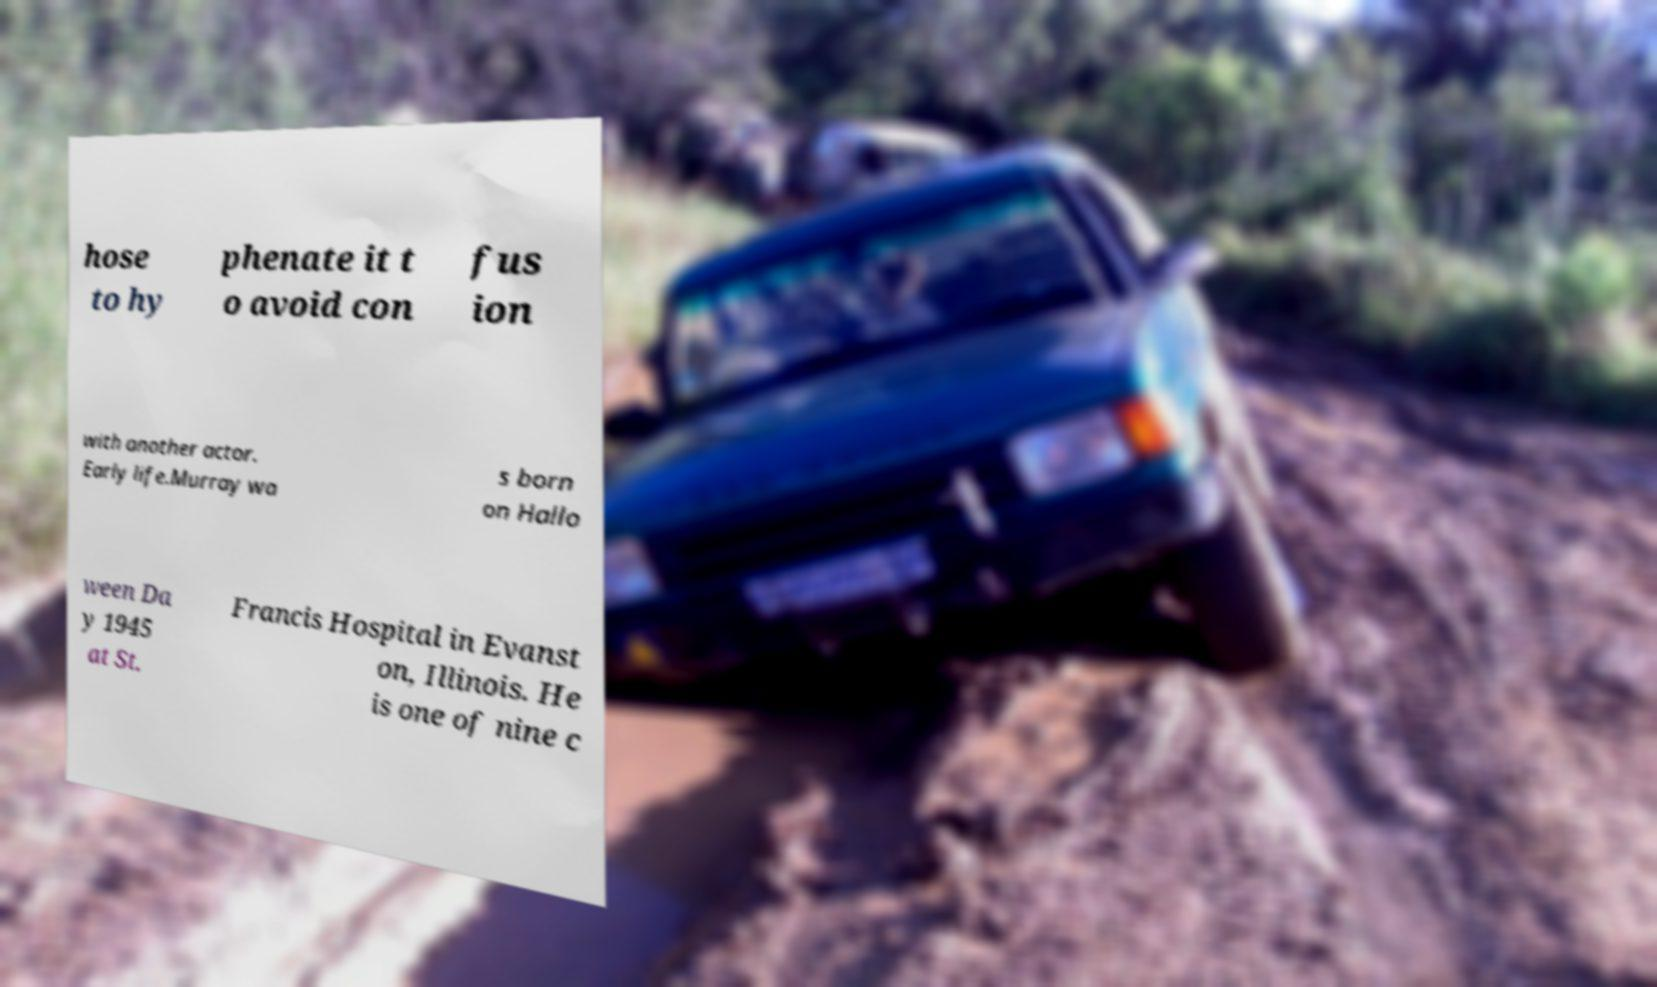For documentation purposes, I need the text within this image transcribed. Could you provide that? hose to hy phenate it t o avoid con fus ion with another actor. Early life.Murray wa s born on Hallo ween Da y 1945 at St. Francis Hospital in Evanst on, Illinois. He is one of nine c 